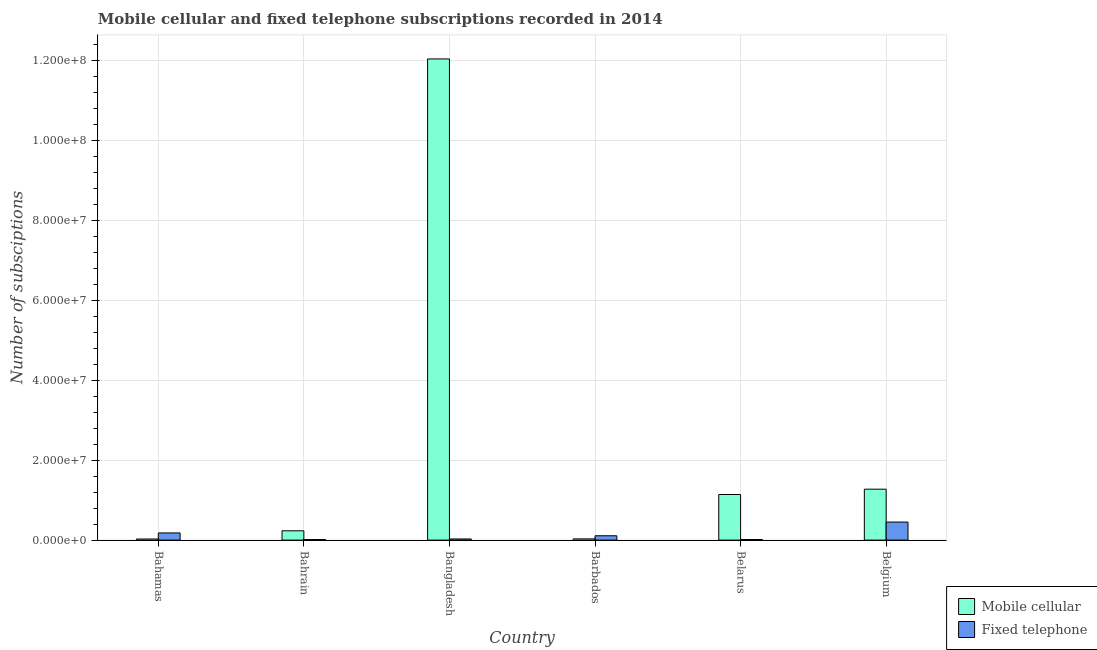How many groups of bars are there?
Provide a succinct answer. 6. Are the number of bars per tick equal to the number of legend labels?
Offer a terse response. Yes. Are the number of bars on each tick of the X-axis equal?
Ensure brevity in your answer.  Yes. How many bars are there on the 6th tick from the left?
Offer a very short reply. 2. What is the label of the 2nd group of bars from the left?
Your answer should be compact. Bahrain. What is the number of mobile cellular subscriptions in Bahrain?
Ensure brevity in your answer.  2.33e+06. Across all countries, what is the maximum number of fixed telephone subscriptions?
Offer a very short reply. 4.51e+06. Across all countries, what is the minimum number of fixed telephone subscriptions?
Provide a succinct answer. 1.38e+05. In which country was the number of mobile cellular subscriptions maximum?
Offer a terse response. Bangladesh. In which country was the number of fixed telephone subscriptions minimum?
Your response must be concise. Bahrain. What is the total number of fixed telephone subscriptions in the graph?
Offer a terse response. 7.97e+06. What is the difference between the number of mobile cellular subscriptions in Bahrain and that in Bangladesh?
Make the answer very short. -1.18e+08. What is the difference between the number of fixed telephone subscriptions in Belarus and the number of mobile cellular subscriptions in Barbados?
Give a very brief answer. -1.54e+05. What is the average number of fixed telephone subscriptions per country?
Provide a short and direct response. 1.33e+06. What is the difference between the number of fixed telephone subscriptions and number of mobile cellular subscriptions in Barbados?
Provide a short and direct response. 7.81e+05. In how many countries, is the number of mobile cellular subscriptions greater than 80000000 ?
Ensure brevity in your answer.  1. What is the ratio of the number of mobile cellular subscriptions in Bahrain to that in Bangladesh?
Offer a very short reply. 0.02. Is the number of fixed telephone subscriptions in Bahamas less than that in Belarus?
Keep it short and to the point. No. What is the difference between the highest and the second highest number of mobile cellular subscriptions?
Give a very brief answer. 1.08e+08. What is the difference between the highest and the lowest number of mobile cellular subscriptions?
Keep it short and to the point. 1.20e+08. In how many countries, is the number of fixed telephone subscriptions greater than the average number of fixed telephone subscriptions taken over all countries?
Offer a terse response. 2. Is the sum of the number of fixed telephone subscriptions in Barbados and Belgium greater than the maximum number of mobile cellular subscriptions across all countries?
Your answer should be very brief. No. What does the 2nd bar from the left in Bahamas represents?
Ensure brevity in your answer.  Fixed telephone. What does the 1st bar from the right in Belarus represents?
Provide a succinct answer. Fixed telephone. Does the graph contain any zero values?
Your response must be concise. No. Does the graph contain grids?
Your answer should be very brief. Yes. How many legend labels are there?
Your answer should be compact. 2. How are the legend labels stacked?
Offer a terse response. Vertical. What is the title of the graph?
Offer a very short reply. Mobile cellular and fixed telephone subscriptions recorded in 2014. What is the label or title of the X-axis?
Give a very brief answer. Country. What is the label or title of the Y-axis?
Ensure brevity in your answer.  Number of subsciptions. What is the Number of subsciptions in Mobile cellular in Bahamas?
Ensure brevity in your answer.  2.73e+05. What is the Number of subsciptions in Fixed telephone in Bahamas?
Provide a succinct answer. 1.80e+06. What is the Number of subsciptions of Mobile cellular in Bahrain?
Your response must be concise. 2.33e+06. What is the Number of subsciptions in Fixed telephone in Bahrain?
Offer a very short reply. 1.38e+05. What is the Number of subsciptions in Mobile cellular in Bangladesh?
Your response must be concise. 1.20e+08. What is the Number of subsciptions in Fixed telephone in Bangladesh?
Give a very brief answer. 2.85e+05. What is the Number of subsciptions in Mobile cellular in Barbados?
Offer a very short reply. 3.05e+05. What is the Number of subsciptions of Fixed telephone in Barbados?
Provide a short and direct response. 1.09e+06. What is the Number of subsciptions in Mobile cellular in Belarus?
Make the answer very short. 1.14e+07. What is the Number of subsciptions in Fixed telephone in Belarus?
Make the answer very short. 1.51e+05. What is the Number of subsciptions of Mobile cellular in Belgium?
Make the answer very short. 1.27e+07. What is the Number of subsciptions of Fixed telephone in Belgium?
Offer a very short reply. 4.51e+06. Across all countries, what is the maximum Number of subsciptions of Mobile cellular?
Give a very brief answer. 1.20e+08. Across all countries, what is the maximum Number of subsciptions of Fixed telephone?
Keep it short and to the point. 4.51e+06. Across all countries, what is the minimum Number of subsciptions of Mobile cellular?
Keep it short and to the point. 2.73e+05. Across all countries, what is the minimum Number of subsciptions of Fixed telephone?
Make the answer very short. 1.38e+05. What is the total Number of subsciptions in Mobile cellular in the graph?
Your answer should be compact. 1.47e+08. What is the total Number of subsciptions in Fixed telephone in the graph?
Make the answer very short. 7.97e+06. What is the difference between the Number of subsciptions of Mobile cellular in Bahamas and that in Bahrain?
Make the answer very short. -2.06e+06. What is the difference between the Number of subsciptions of Fixed telephone in Bahamas and that in Bahrain?
Your answer should be very brief. 1.66e+06. What is the difference between the Number of subsciptions of Mobile cellular in Bahamas and that in Bangladesh?
Your answer should be compact. -1.20e+08. What is the difference between the Number of subsciptions of Fixed telephone in Bahamas and that in Bangladesh?
Provide a succinct answer. 1.51e+06. What is the difference between the Number of subsciptions in Mobile cellular in Bahamas and that in Barbados?
Ensure brevity in your answer.  -3.22e+04. What is the difference between the Number of subsciptions in Fixed telephone in Bahamas and that in Barbados?
Provide a short and direct response. 7.09e+05. What is the difference between the Number of subsciptions of Mobile cellular in Bahamas and that in Belarus?
Your answer should be very brief. -1.11e+07. What is the difference between the Number of subsciptions of Fixed telephone in Bahamas and that in Belarus?
Offer a very short reply. 1.64e+06. What is the difference between the Number of subsciptions in Mobile cellular in Bahamas and that in Belgium?
Keep it short and to the point. -1.25e+07. What is the difference between the Number of subsciptions in Fixed telephone in Bahamas and that in Belgium?
Keep it short and to the point. -2.72e+06. What is the difference between the Number of subsciptions of Mobile cellular in Bahrain and that in Bangladesh?
Offer a very short reply. -1.18e+08. What is the difference between the Number of subsciptions in Fixed telephone in Bahrain and that in Bangladesh?
Offer a terse response. -1.47e+05. What is the difference between the Number of subsciptions of Mobile cellular in Bahrain and that in Barbados?
Give a very brief answer. 2.02e+06. What is the difference between the Number of subsciptions of Fixed telephone in Bahrain and that in Barbados?
Give a very brief answer. -9.49e+05. What is the difference between the Number of subsciptions of Mobile cellular in Bahrain and that in Belarus?
Keep it short and to the point. -9.07e+06. What is the difference between the Number of subsciptions in Fixed telephone in Bahrain and that in Belarus?
Your answer should be very brief. -1.37e+04. What is the difference between the Number of subsciptions in Mobile cellular in Bahrain and that in Belgium?
Give a very brief answer. -1.04e+07. What is the difference between the Number of subsciptions in Fixed telephone in Bahrain and that in Belgium?
Provide a short and direct response. -4.38e+06. What is the difference between the Number of subsciptions of Mobile cellular in Bangladesh and that in Barbados?
Your answer should be very brief. 1.20e+08. What is the difference between the Number of subsciptions in Fixed telephone in Bangladesh and that in Barbados?
Offer a very short reply. -8.02e+05. What is the difference between the Number of subsciptions of Mobile cellular in Bangladesh and that in Belarus?
Keep it short and to the point. 1.09e+08. What is the difference between the Number of subsciptions of Fixed telephone in Bangladesh and that in Belarus?
Keep it short and to the point. 1.33e+05. What is the difference between the Number of subsciptions in Mobile cellular in Bangladesh and that in Belgium?
Make the answer very short. 1.08e+08. What is the difference between the Number of subsciptions in Fixed telephone in Bangladesh and that in Belgium?
Make the answer very short. -4.23e+06. What is the difference between the Number of subsciptions of Mobile cellular in Barbados and that in Belarus?
Give a very brief answer. -1.11e+07. What is the difference between the Number of subsciptions in Fixed telephone in Barbados and that in Belarus?
Provide a succinct answer. 9.35e+05. What is the difference between the Number of subsciptions in Mobile cellular in Barbados and that in Belgium?
Ensure brevity in your answer.  -1.24e+07. What is the difference between the Number of subsciptions in Fixed telephone in Barbados and that in Belgium?
Your response must be concise. -3.43e+06. What is the difference between the Number of subsciptions of Mobile cellular in Belarus and that in Belgium?
Ensure brevity in your answer.  -1.33e+06. What is the difference between the Number of subsciptions of Fixed telephone in Belarus and that in Belgium?
Provide a succinct answer. -4.36e+06. What is the difference between the Number of subsciptions of Mobile cellular in Bahamas and the Number of subsciptions of Fixed telephone in Bahrain?
Keep it short and to the point. 1.36e+05. What is the difference between the Number of subsciptions in Mobile cellular in Bahamas and the Number of subsciptions in Fixed telephone in Bangladesh?
Your response must be concise. -1.14e+04. What is the difference between the Number of subsciptions of Mobile cellular in Bahamas and the Number of subsciptions of Fixed telephone in Barbados?
Give a very brief answer. -8.13e+05. What is the difference between the Number of subsciptions in Mobile cellular in Bahamas and the Number of subsciptions in Fixed telephone in Belarus?
Keep it short and to the point. 1.22e+05. What is the difference between the Number of subsciptions of Mobile cellular in Bahamas and the Number of subsciptions of Fixed telephone in Belgium?
Provide a succinct answer. -4.24e+06. What is the difference between the Number of subsciptions in Mobile cellular in Bahrain and the Number of subsciptions in Fixed telephone in Bangladesh?
Your response must be concise. 2.04e+06. What is the difference between the Number of subsciptions of Mobile cellular in Bahrain and the Number of subsciptions of Fixed telephone in Barbados?
Your response must be concise. 1.24e+06. What is the difference between the Number of subsciptions in Mobile cellular in Bahrain and the Number of subsciptions in Fixed telephone in Belarus?
Offer a terse response. 2.18e+06. What is the difference between the Number of subsciptions of Mobile cellular in Bahrain and the Number of subsciptions of Fixed telephone in Belgium?
Provide a short and direct response. -2.19e+06. What is the difference between the Number of subsciptions in Mobile cellular in Bangladesh and the Number of subsciptions in Fixed telephone in Barbados?
Make the answer very short. 1.19e+08. What is the difference between the Number of subsciptions in Mobile cellular in Bangladesh and the Number of subsciptions in Fixed telephone in Belarus?
Your response must be concise. 1.20e+08. What is the difference between the Number of subsciptions in Mobile cellular in Bangladesh and the Number of subsciptions in Fixed telephone in Belgium?
Offer a very short reply. 1.16e+08. What is the difference between the Number of subsciptions in Mobile cellular in Barbados and the Number of subsciptions in Fixed telephone in Belarus?
Your answer should be compact. 1.54e+05. What is the difference between the Number of subsciptions of Mobile cellular in Barbados and the Number of subsciptions of Fixed telephone in Belgium?
Make the answer very short. -4.21e+06. What is the difference between the Number of subsciptions of Mobile cellular in Belarus and the Number of subsciptions of Fixed telephone in Belgium?
Keep it short and to the point. 6.89e+06. What is the average Number of subsciptions of Mobile cellular per country?
Make the answer very short. 2.46e+07. What is the average Number of subsciptions of Fixed telephone per country?
Make the answer very short. 1.33e+06. What is the difference between the Number of subsciptions of Mobile cellular and Number of subsciptions of Fixed telephone in Bahamas?
Your response must be concise. -1.52e+06. What is the difference between the Number of subsciptions of Mobile cellular and Number of subsciptions of Fixed telephone in Bahrain?
Your response must be concise. 2.19e+06. What is the difference between the Number of subsciptions in Mobile cellular and Number of subsciptions in Fixed telephone in Bangladesh?
Provide a succinct answer. 1.20e+08. What is the difference between the Number of subsciptions of Mobile cellular and Number of subsciptions of Fixed telephone in Barbados?
Your response must be concise. -7.81e+05. What is the difference between the Number of subsciptions of Mobile cellular and Number of subsciptions of Fixed telephone in Belarus?
Your answer should be very brief. 1.13e+07. What is the difference between the Number of subsciptions of Mobile cellular and Number of subsciptions of Fixed telephone in Belgium?
Your answer should be compact. 8.22e+06. What is the ratio of the Number of subsciptions in Mobile cellular in Bahamas to that in Bahrain?
Your answer should be compact. 0.12. What is the ratio of the Number of subsciptions in Fixed telephone in Bahamas to that in Bahrain?
Your response must be concise. 13.04. What is the ratio of the Number of subsciptions of Mobile cellular in Bahamas to that in Bangladesh?
Give a very brief answer. 0. What is the ratio of the Number of subsciptions of Fixed telephone in Bahamas to that in Bangladesh?
Offer a terse response. 6.31. What is the ratio of the Number of subsciptions in Mobile cellular in Bahamas to that in Barbados?
Keep it short and to the point. 0.89. What is the ratio of the Number of subsciptions of Fixed telephone in Bahamas to that in Barbados?
Offer a terse response. 1.65. What is the ratio of the Number of subsciptions in Mobile cellular in Bahamas to that in Belarus?
Provide a succinct answer. 0.02. What is the ratio of the Number of subsciptions of Fixed telephone in Bahamas to that in Belarus?
Your answer should be very brief. 11.86. What is the ratio of the Number of subsciptions of Mobile cellular in Bahamas to that in Belgium?
Keep it short and to the point. 0.02. What is the ratio of the Number of subsciptions of Fixed telephone in Bahamas to that in Belgium?
Your response must be concise. 0.4. What is the ratio of the Number of subsciptions in Mobile cellular in Bahrain to that in Bangladesh?
Your response must be concise. 0.02. What is the ratio of the Number of subsciptions in Fixed telephone in Bahrain to that in Bangladesh?
Offer a very short reply. 0.48. What is the ratio of the Number of subsciptions of Mobile cellular in Bahrain to that in Barbados?
Provide a short and direct response. 7.62. What is the ratio of the Number of subsciptions in Fixed telephone in Bahrain to that in Barbados?
Provide a succinct answer. 0.13. What is the ratio of the Number of subsciptions of Mobile cellular in Bahrain to that in Belarus?
Offer a terse response. 0.2. What is the ratio of the Number of subsciptions in Fixed telephone in Bahrain to that in Belarus?
Your answer should be very brief. 0.91. What is the ratio of the Number of subsciptions of Mobile cellular in Bahrain to that in Belgium?
Make the answer very short. 0.18. What is the ratio of the Number of subsciptions of Fixed telephone in Bahrain to that in Belgium?
Make the answer very short. 0.03. What is the ratio of the Number of subsciptions in Mobile cellular in Bangladesh to that in Barbados?
Your response must be concise. 394. What is the ratio of the Number of subsciptions in Fixed telephone in Bangladesh to that in Barbados?
Give a very brief answer. 0.26. What is the ratio of the Number of subsciptions in Mobile cellular in Bangladesh to that in Belarus?
Keep it short and to the point. 10.56. What is the ratio of the Number of subsciptions in Fixed telephone in Bangladesh to that in Belarus?
Give a very brief answer. 1.88. What is the ratio of the Number of subsciptions of Mobile cellular in Bangladesh to that in Belgium?
Offer a terse response. 9.45. What is the ratio of the Number of subsciptions of Fixed telephone in Bangladesh to that in Belgium?
Give a very brief answer. 0.06. What is the ratio of the Number of subsciptions of Mobile cellular in Barbados to that in Belarus?
Offer a terse response. 0.03. What is the ratio of the Number of subsciptions in Fixed telephone in Barbados to that in Belarus?
Provide a short and direct response. 7.18. What is the ratio of the Number of subsciptions in Mobile cellular in Barbados to that in Belgium?
Your answer should be compact. 0.02. What is the ratio of the Number of subsciptions of Fixed telephone in Barbados to that in Belgium?
Offer a very short reply. 0.24. What is the ratio of the Number of subsciptions in Mobile cellular in Belarus to that in Belgium?
Keep it short and to the point. 0.9. What is the ratio of the Number of subsciptions of Fixed telephone in Belarus to that in Belgium?
Make the answer very short. 0.03. What is the difference between the highest and the second highest Number of subsciptions of Mobile cellular?
Offer a very short reply. 1.08e+08. What is the difference between the highest and the second highest Number of subsciptions in Fixed telephone?
Provide a short and direct response. 2.72e+06. What is the difference between the highest and the lowest Number of subsciptions of Mobile cellular?
Your answer should be very brief. 1.20e+08. What is the difference between the highest and the lowest Number of subsciptions in Fixed telephone?
Offer a terse response. 4.38e+06. 